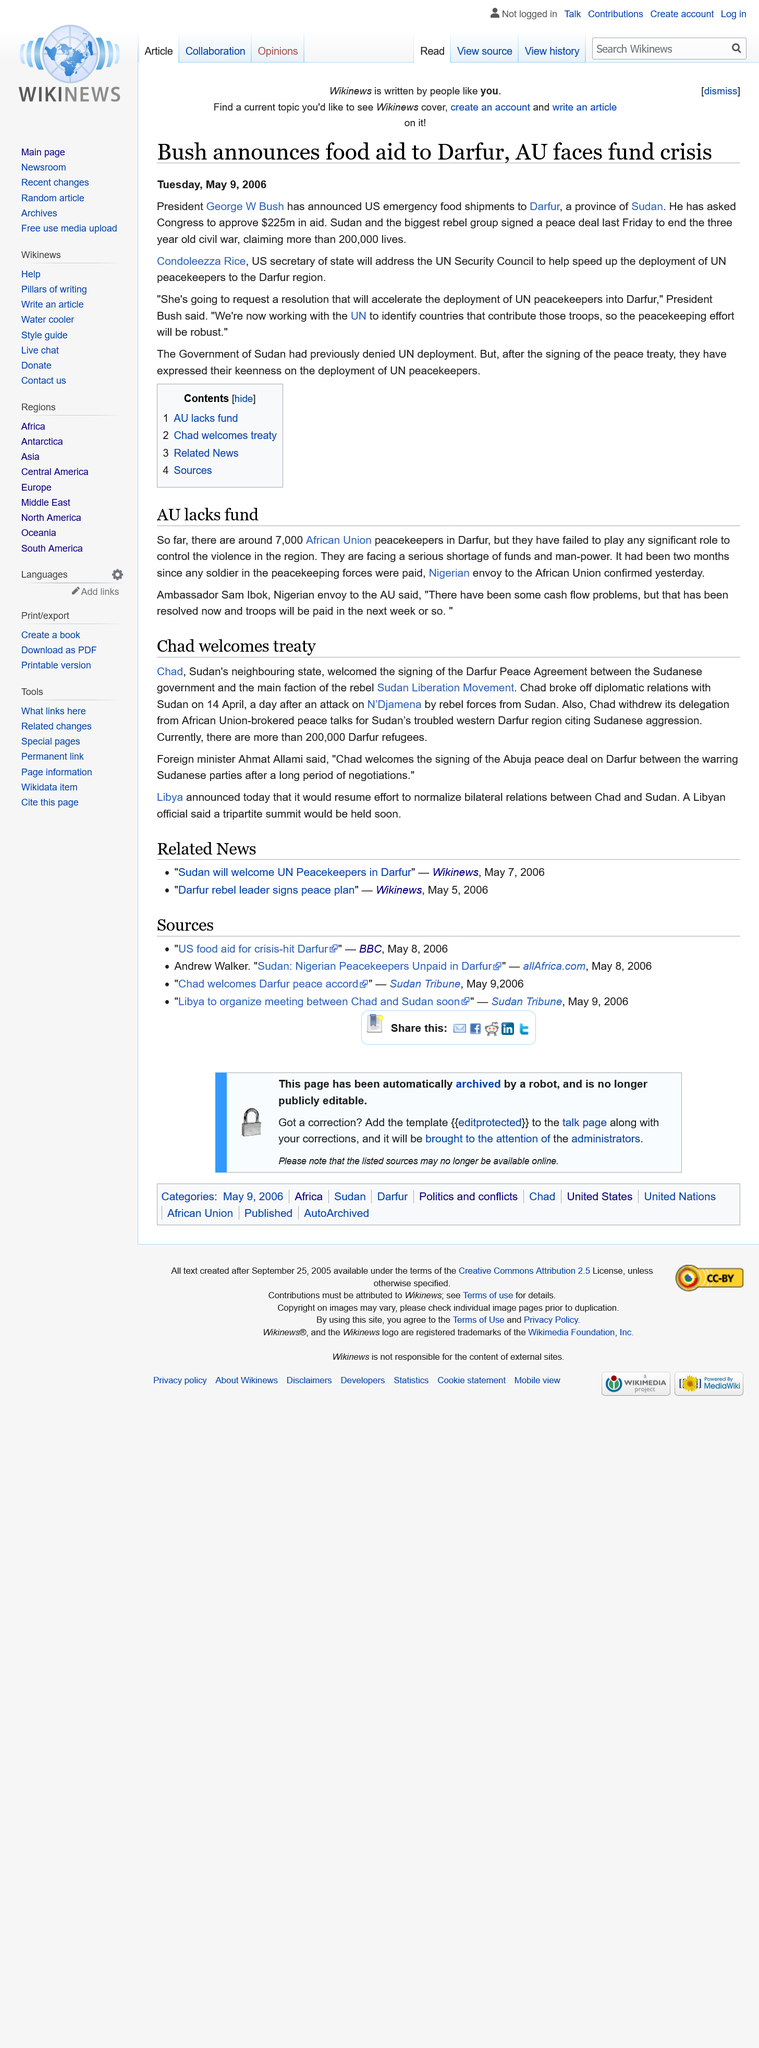Give some essential details in this illustration. Condoleezza Rice is the Secretary of State of the United States. President George W. Bush announced an emergency food shipment to the people of Darfur in response to the ongoing crisis in the region. I, [Name], declare that the article about food aid to Darfur was published on Tuesday, May 9, 2006. 